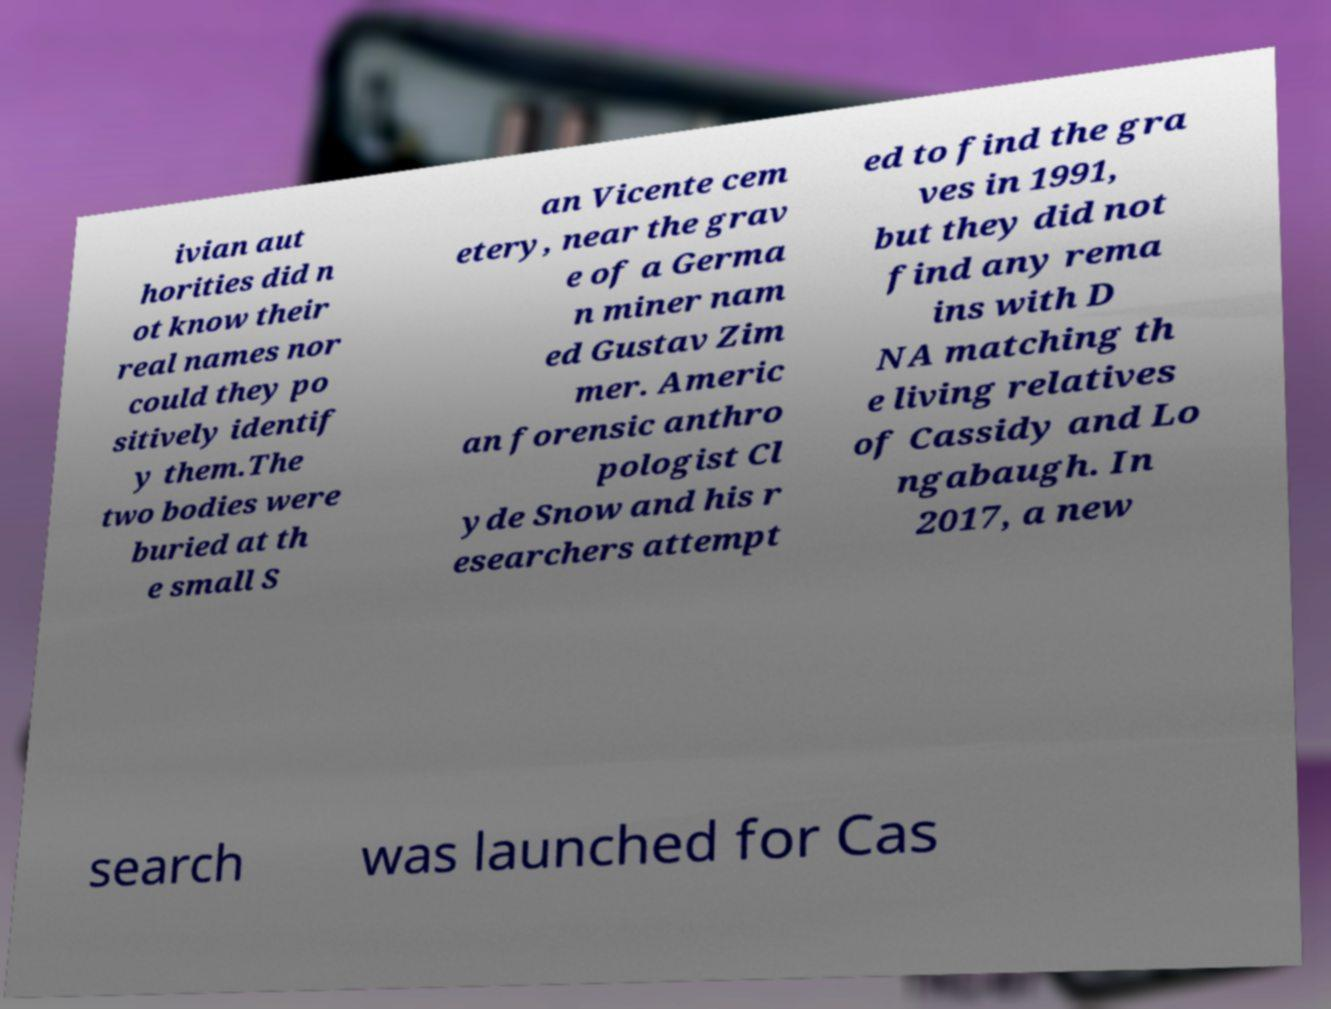Could you extract and type out the text from this image? ivian aut horities did n ot know their real names nor could they po sitively identif y them.The two bodies were buried at th e small S an Vicente cem etery, near the grav e of a Germa n miner nam ed Gustav Zim mer. Americ an forensic anthro pologist Cl yde Snow and his r esearchers attempt ed to find the gra ves in 1991, but they did not find any rema ins with D NA matching th e living relatives of Cassidy and Lo ngabaugh. In 2017, a new search was launched for Cas 